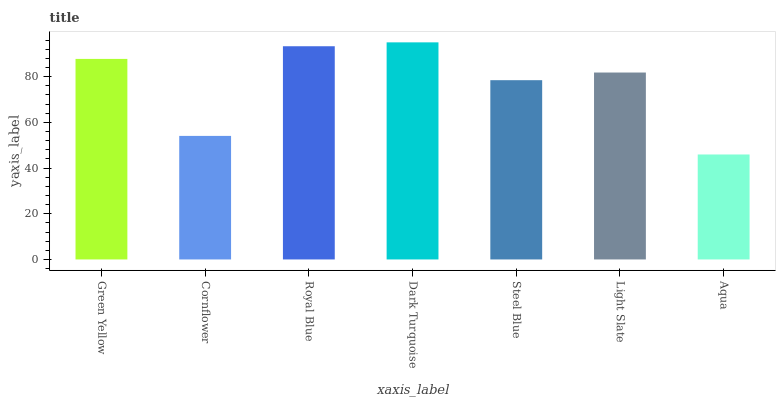Is Aqua the minimum?
Answer yes or no. Yes. Is Dark Turquoise the maximum?
Answer yes or no. Yes. Is Cornflower the minimum?
Answer yes or no. No. Is Cornflower the maximum?
Answer yes or no. No. Is Green Yellow greater than Cornflower?
Answer yes or no. Yes. Is Cornflower less than Green Yellow?
Answer yes or no. Yes. Is Cornflower greater than Green Yellow?
Answer yes or no. No. Is Green Yellow less than Cornflower?
Answer yes or no. No. Is Light Slate the high median?
Answer yes or no. Yes. Is Light Slate the low median?
Answer yes or no. Yes. Is Steel Blue the high median?
Answer yes or no. No. Is Steel Blue the low median?
Answer yes or no. No. 